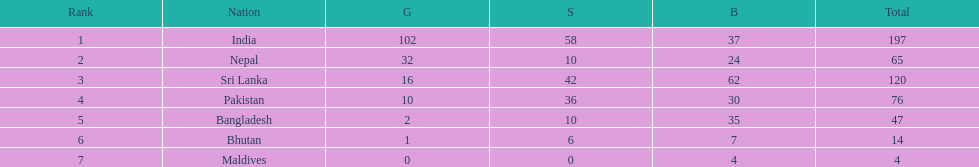Who has won the most bronze medals? Sri Lanka. 